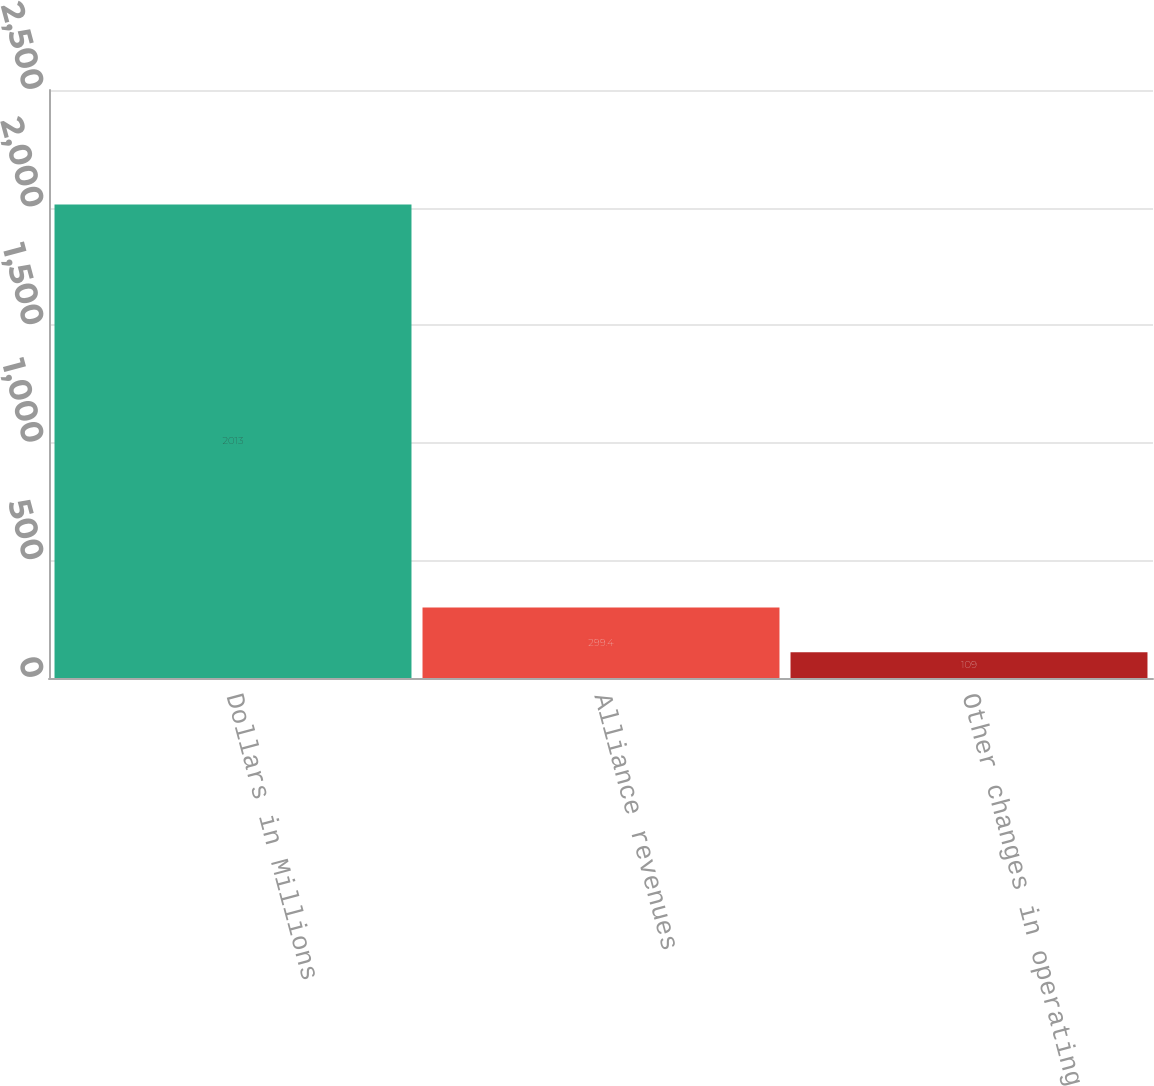Convert chart. <chart><loc_0><loc_0><loc_500><loc_500><bar_chart><fcel>Dollars in Millions<fcel>Alliance revenues<fcel>Other changes in operating<nl><fcel>2013<fcel>299.4<fcel>109<nl></chart> 